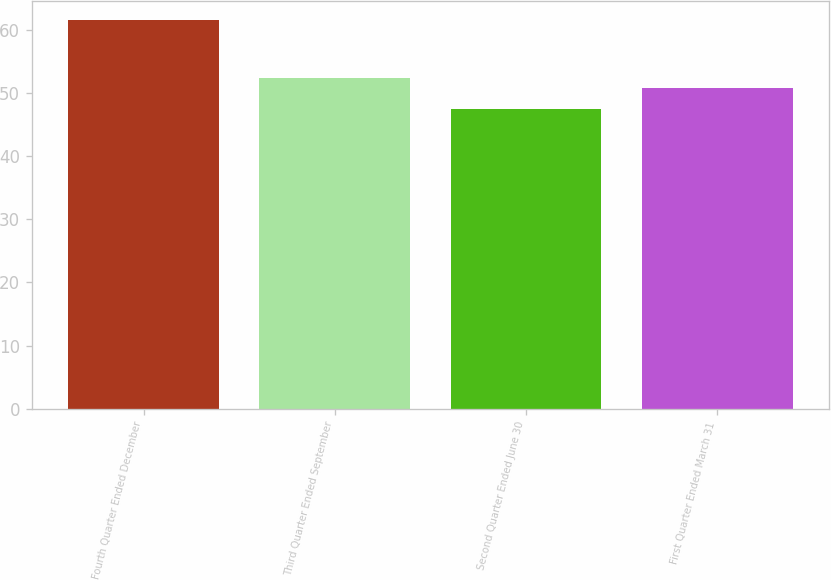Convert chart to OTSL. <chart><loc_0><loc_0><loc_500><loc_500><bar_chart><fcel>Fourth Quarter Ended December<fcel>Third Quarter Ended September<fcel>Second Quarter Ended June 30<fcel>First Quarter Ended March 31<nl><fcel>61.5<fcel>52.42<fcel>47.47<fcel>50.77<nl></chart> 